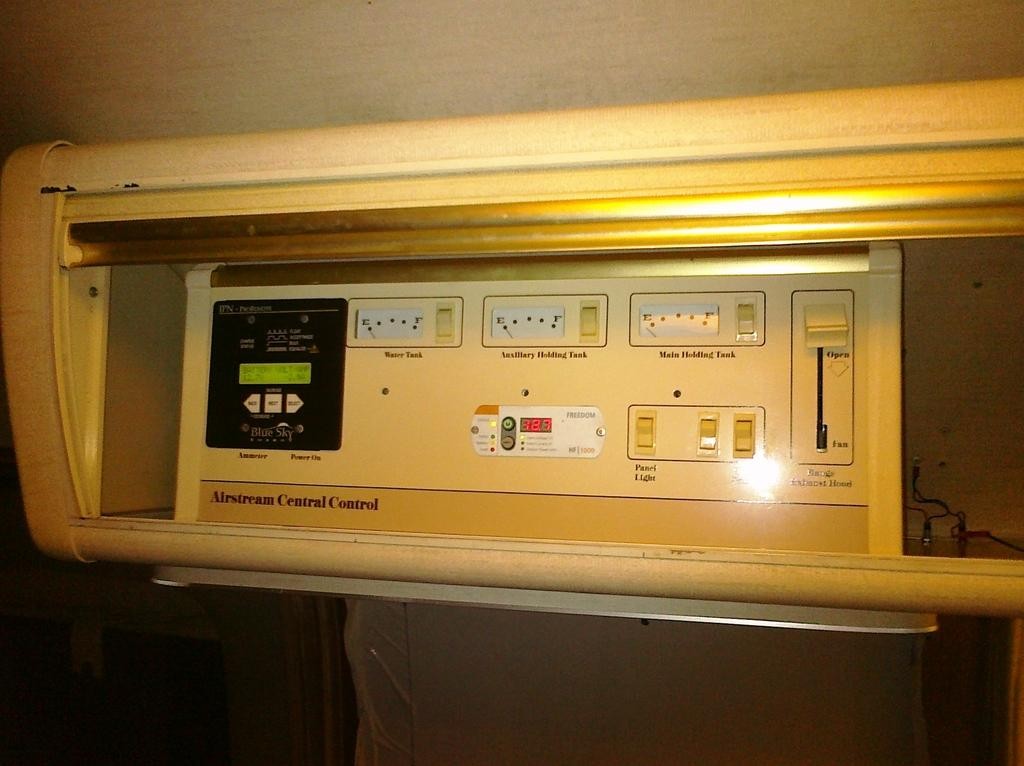What type of object can be seen in the image that requires electricity? There is an electrical object in the image. What can be seen on the right side of the image? There are wires on the right side of the image. What type of leather shoes can be seen on the toes of the person in the image? There is no person or leather shoes present in the image. What type of volleyball game is being played in the image? There is no volleyball game present in the image. 